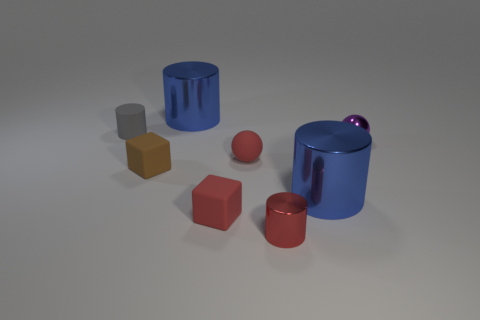There is a small metal object that is the same shape as the tiny gray rubber object; what color is it?
Give a very brief answer. Red. Is the shape of the purple thing the same as the small gray thing?
Give a very brief answer. No. What number of cylinders are either small rubber things or small gray things?
Make the answer very short. 1. There is another small block that is made of the same material as the brown block; what color is it?
Your answer should be very brief. Red. Do the blue cylinder that is in front of the shiny sphere and the rubber sphere have the same size?
Give a very brief answer. No. Is the material of the red cube the same as the small cylinder that is behind the small red rubber block?
Your response must be concise. Yes. There is a large cylinder that is on the left side of the small metal cylinder; what color is it?
Offer a terse response. Blue. Are there any red matte spheres that are to the left of the small ball that is on the left side of the tiny purple ball?
Your response must be concise. No. Does the cylinder that is right of the small red shiny cylinder have the same color as the big metal thing that is behind the gray rubber cylinder?
Give a very brief answer. Yes. There is a tiny red cube; what number of red things are right of it?
Keep it short and to the point. 2. 